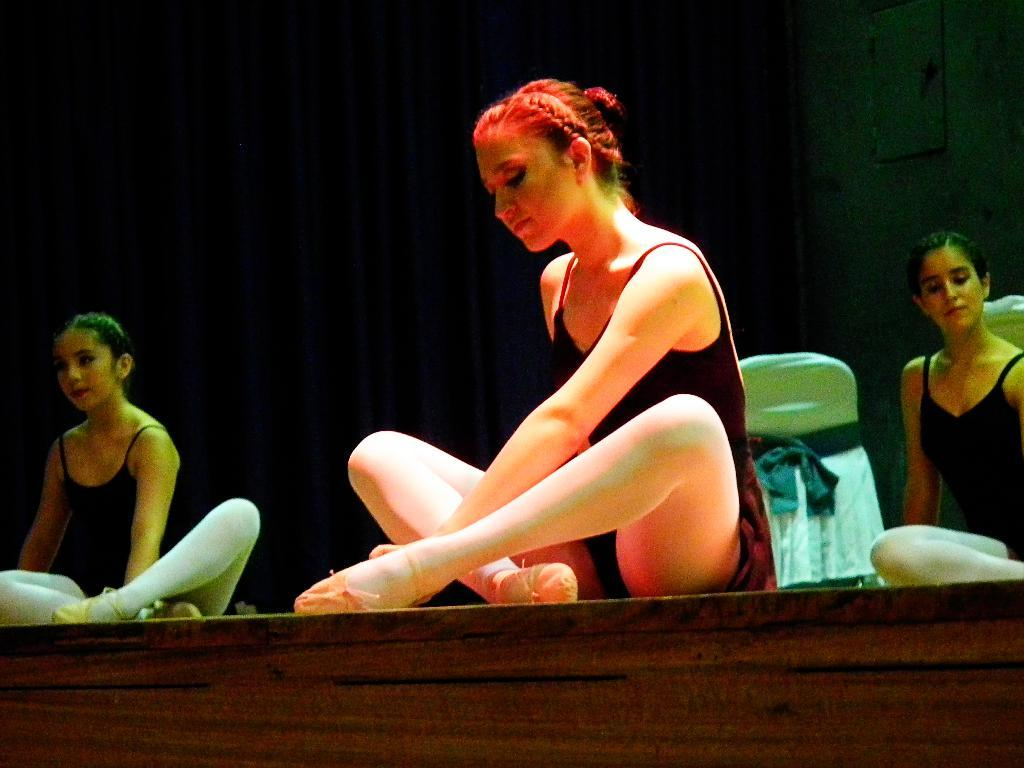How many women are sitting on the stage in the image? There are three women sitting on the stage in the image. What can be seen behind the women on the stage? There is a curtain visible in the image. Can you describe any furniture or props on the stage? There is a chair dressed with a cloth in the image. What type of vest can be seen hanging on the chair in the image? There is no vest present in the image; only a chair dressed with a cloth is visible. 